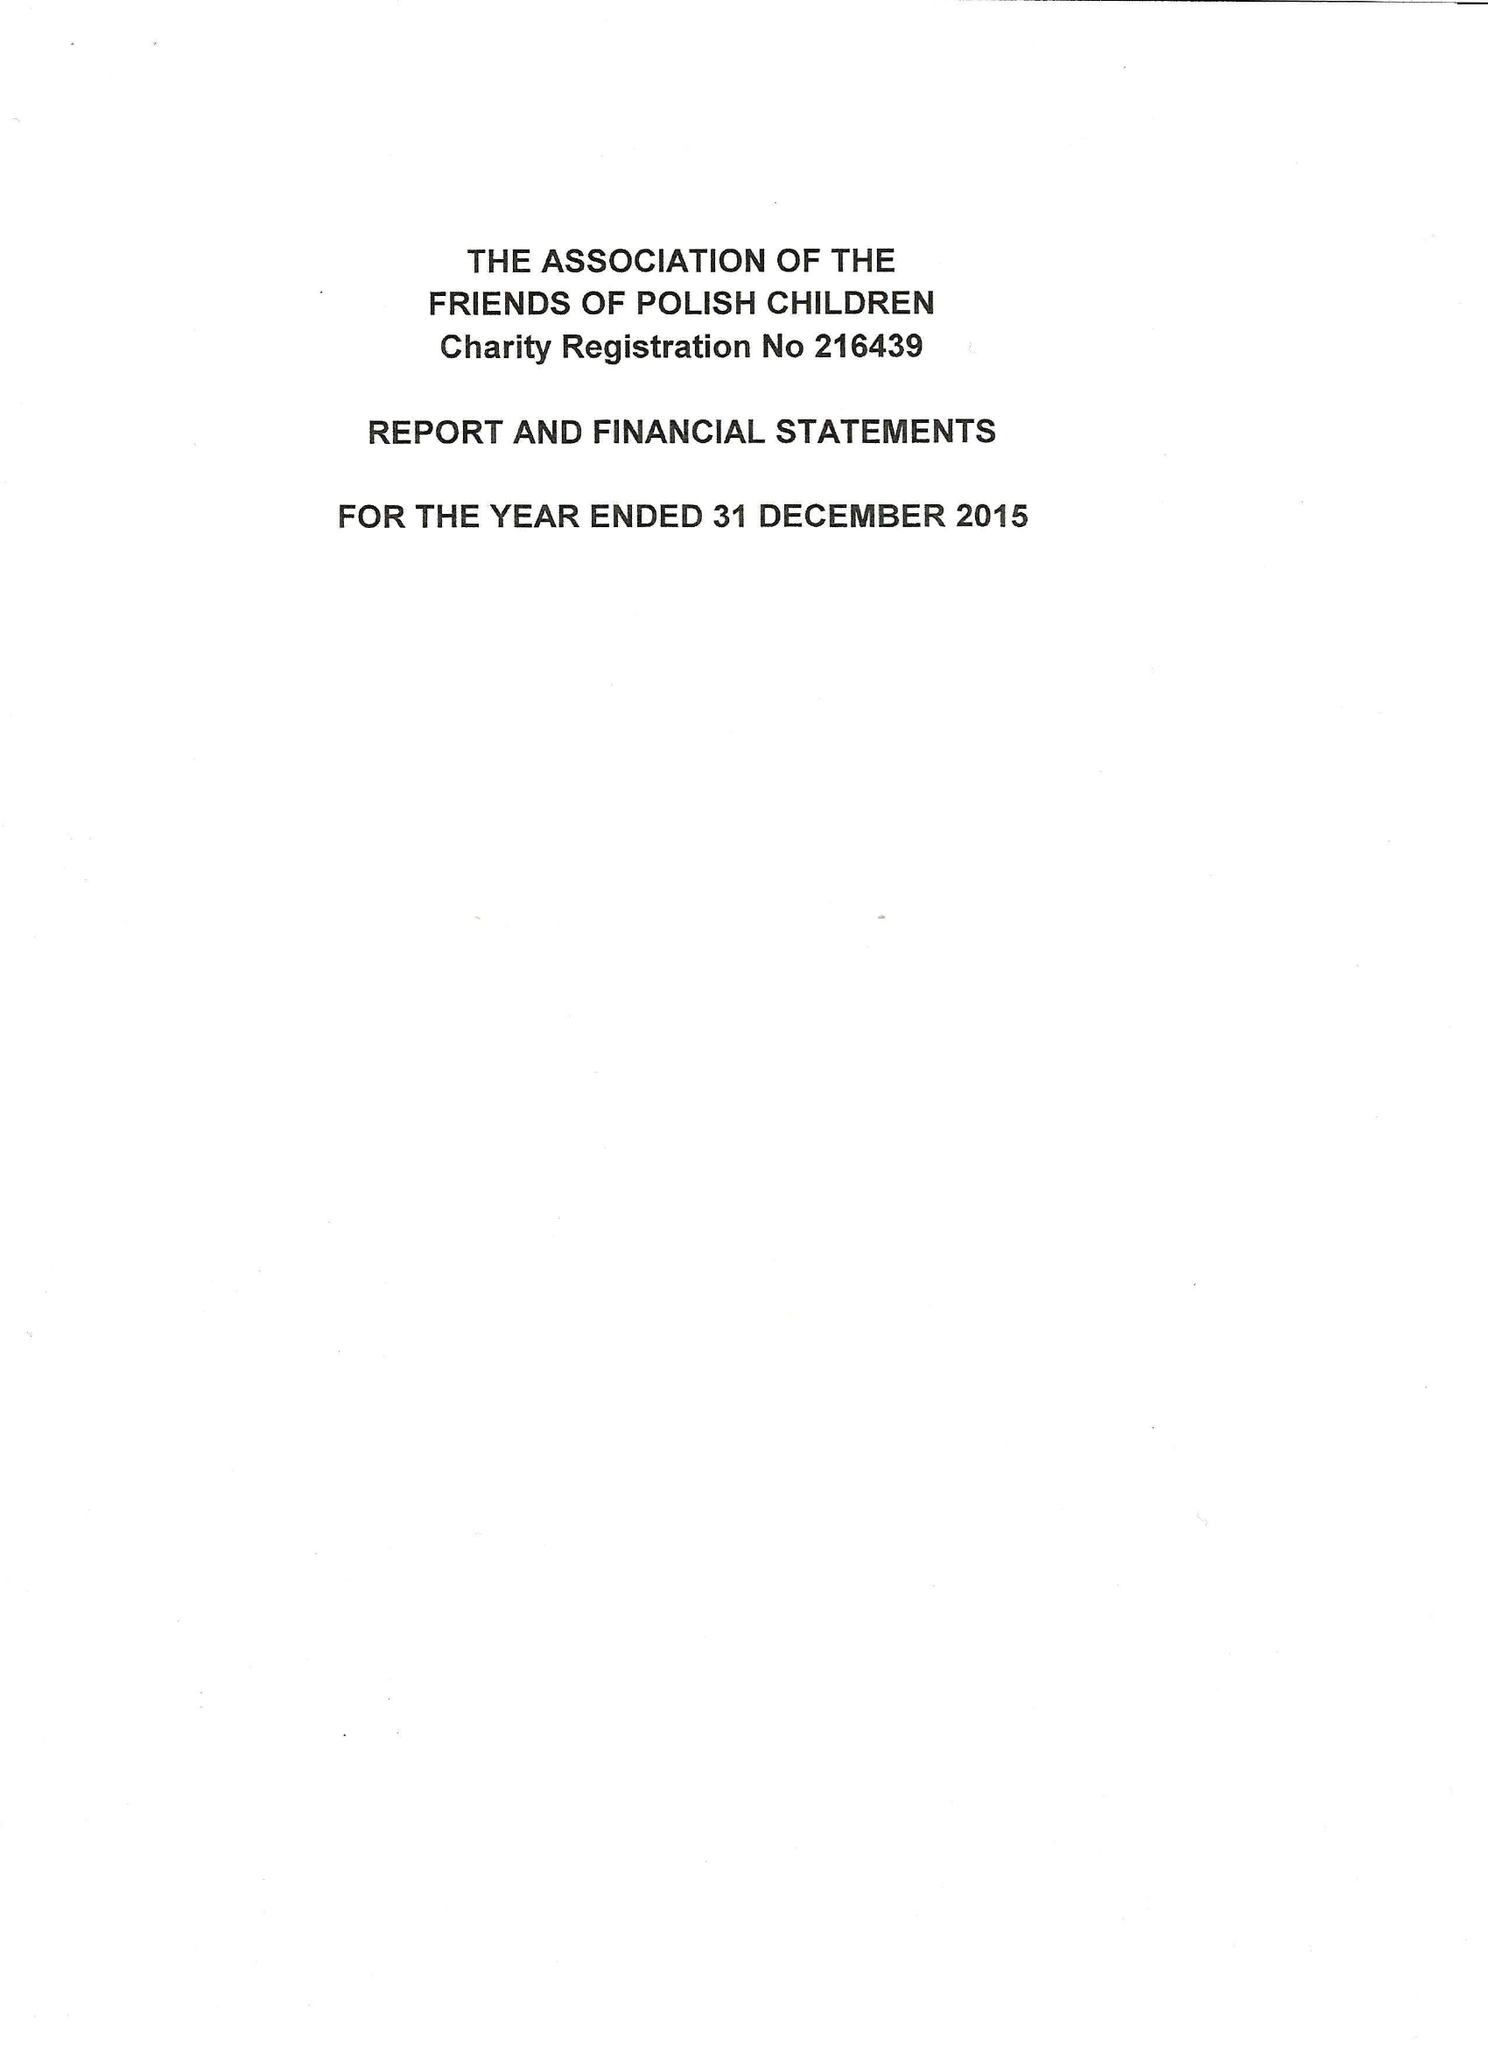What is the value for the address__postcode?
Answer the question using a single word or phrase. SW12 9LU 